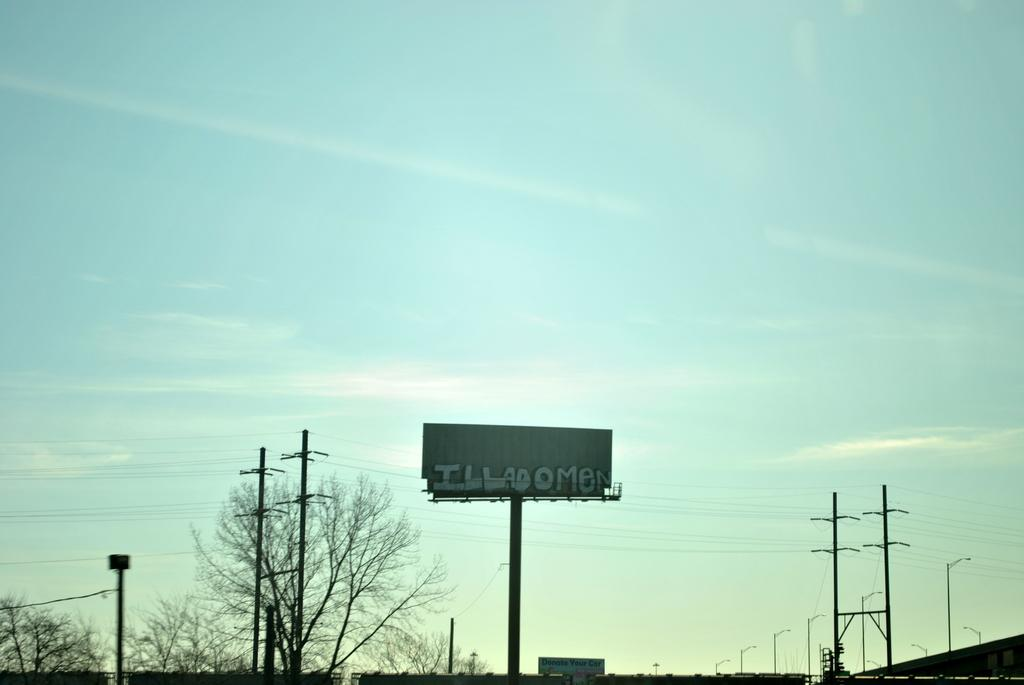<image>
Relay a brief, clear account of the picture shown. The back side of a high rise sign reads ILLADOMEN. 